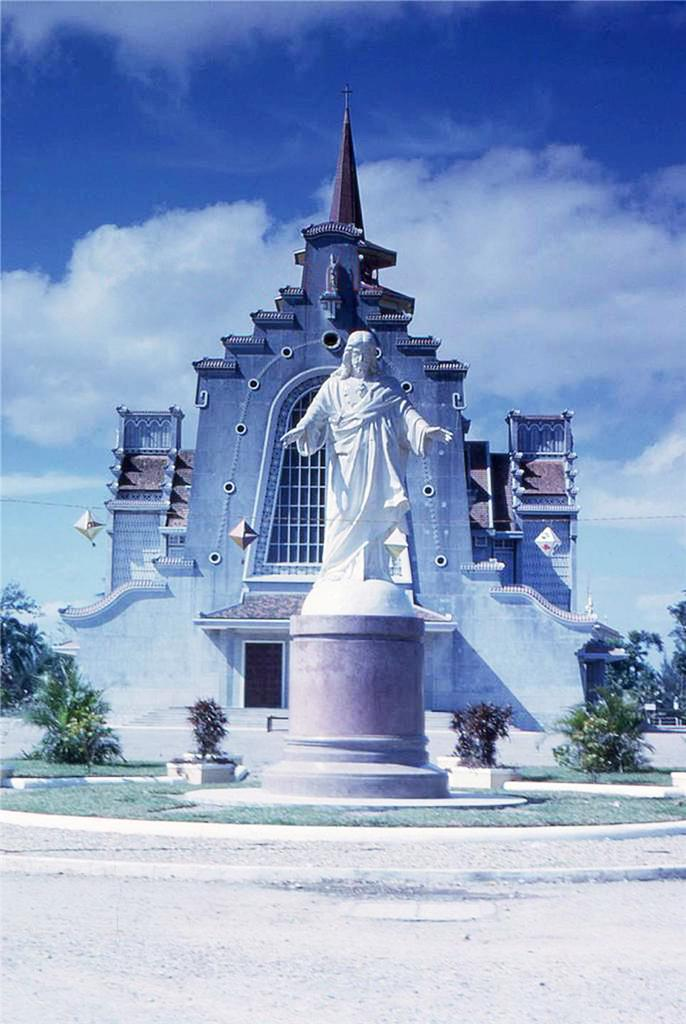What is the main structure in the picture? There is a building in the picture. What can be seen in front of the building? There is a white color Jesus statue in front of the building. What is present on either side of the statue? There are plants on either side of the statue. What type of beetle can be seen crawling on the statue in the image? There is no beetle present on the statue in the image. What is the temper of the statue in the image? The statue is an inanimate object and does not have a temper. 